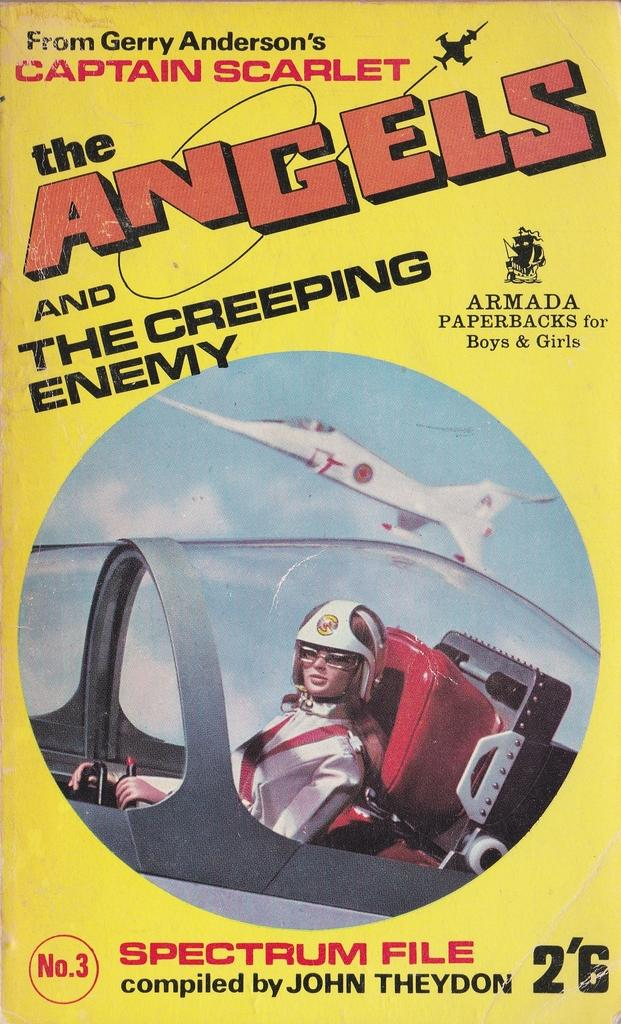What type of visual is the image? The image is a poster. What is depicted on the poster? There is a depiction of an aeroplane and a person on the poster. Are there any words on the poster? Yes, there is text printed on the poster. What type of vegetable is the person holding in the image? There is no vegetable present in the image; the poster depicts an aeroplane and a person, but no vegetable. 